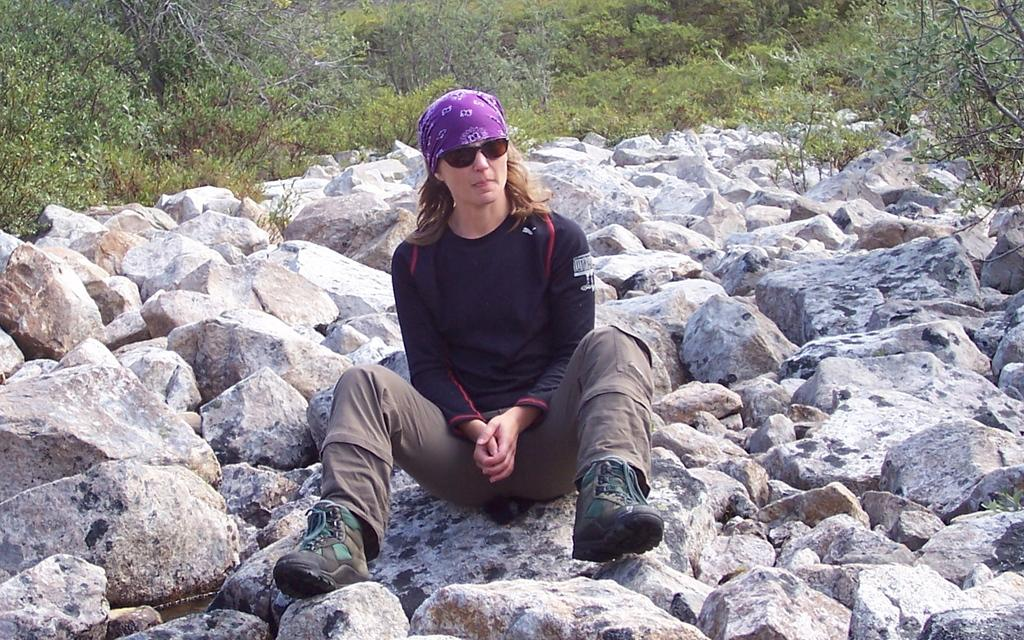Who or what is the main subject in the image? There is a person in the image. What is the person doing in the image? The person is sitting on a stone. What can be seen in the background of the image? There are trees in the background of the image. What type of company is the person working for in the image? There is no indication of a company or any work-related context in the image. 